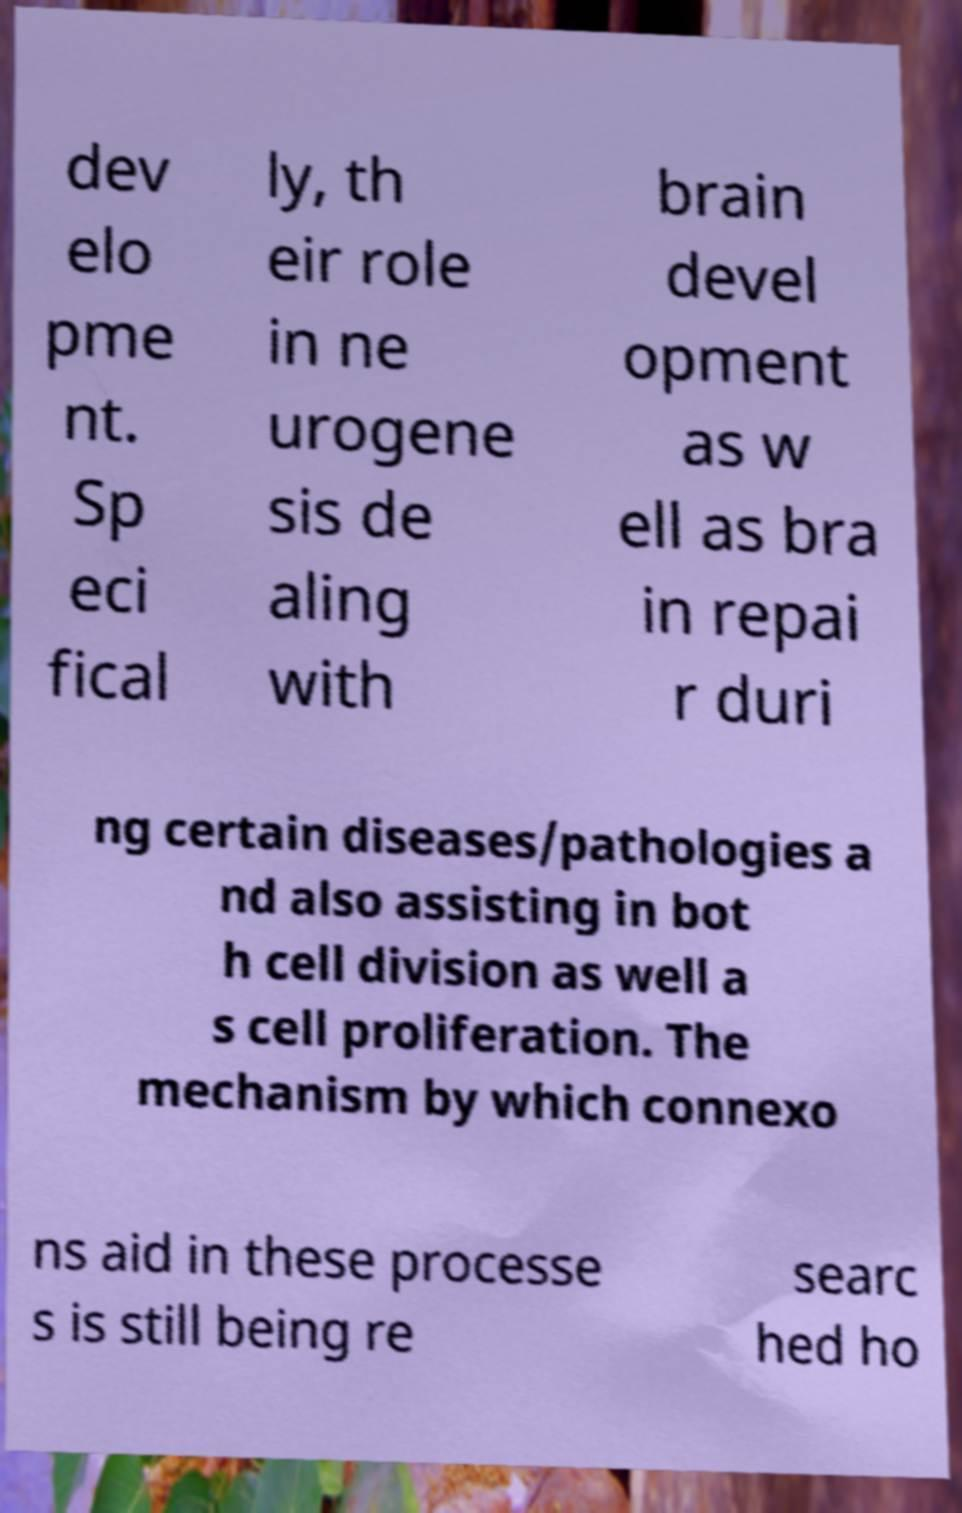Could you assist in decoding the text presented in this image and type it out clearly? dev elo pme nt. Sp eci fical ly, th eir role in ne urogene sis de aling with brain devel opment as w ell as bra in repai r duri ng certain diseases/pathologies a nd also assisting in bot h cell division as well a s cell proliferation. The mechanism by which connexo ns aid in these processe s is still being re searc hed ho 